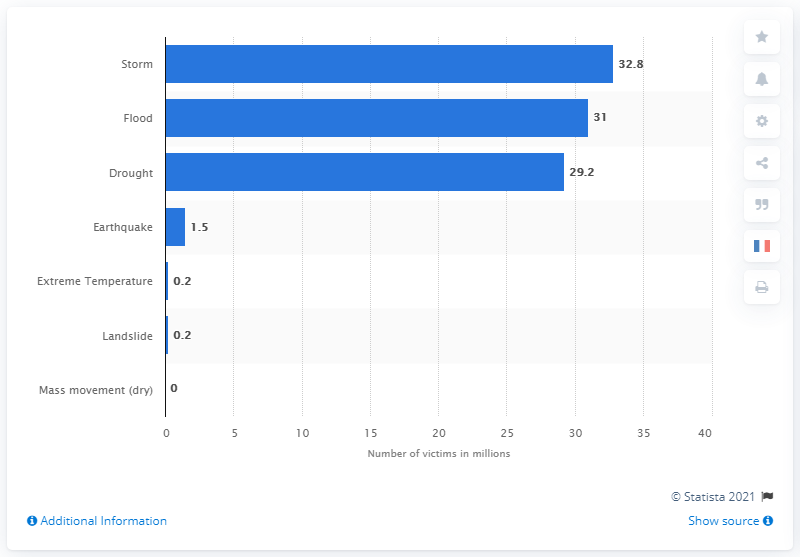Give some essential details in this illustration. In 2019, it is estimated that 31 people were affected by floods. 